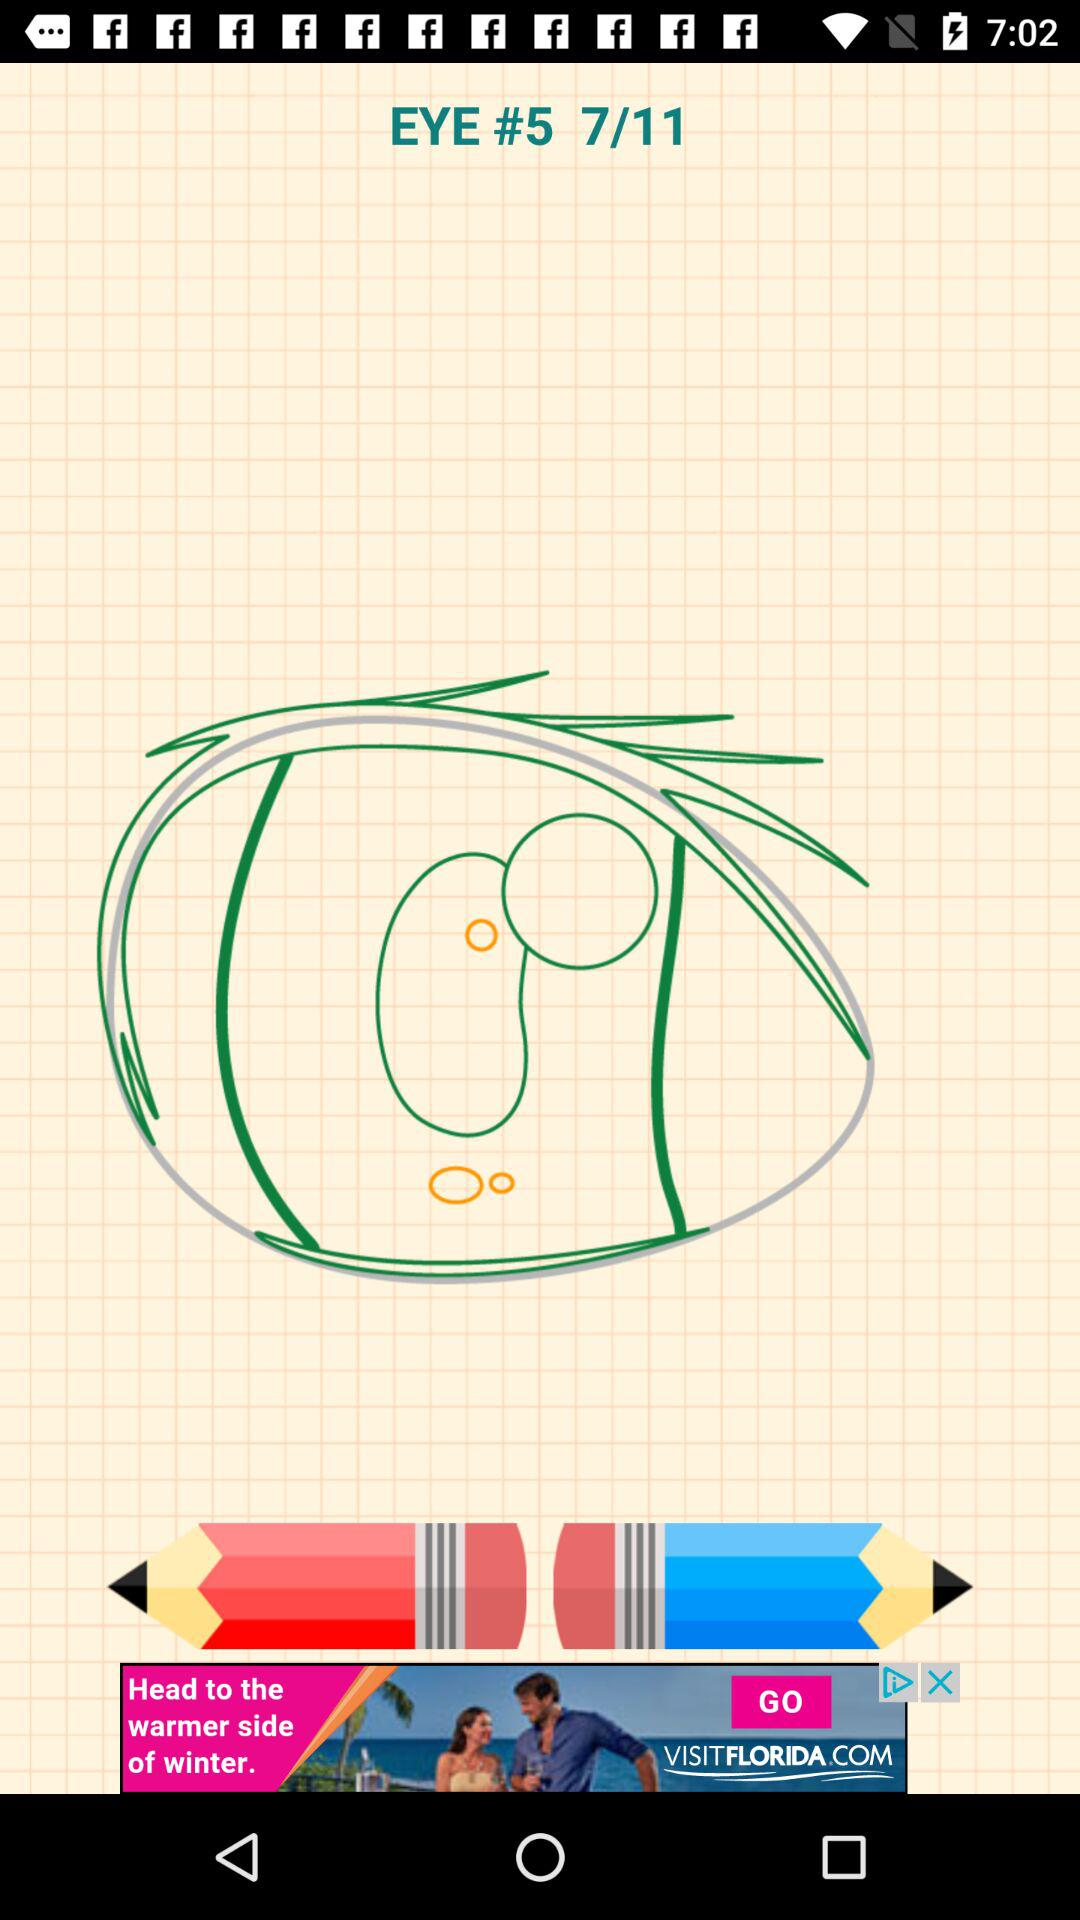What is the topic name given on the screen? The topic name is "EYE". 